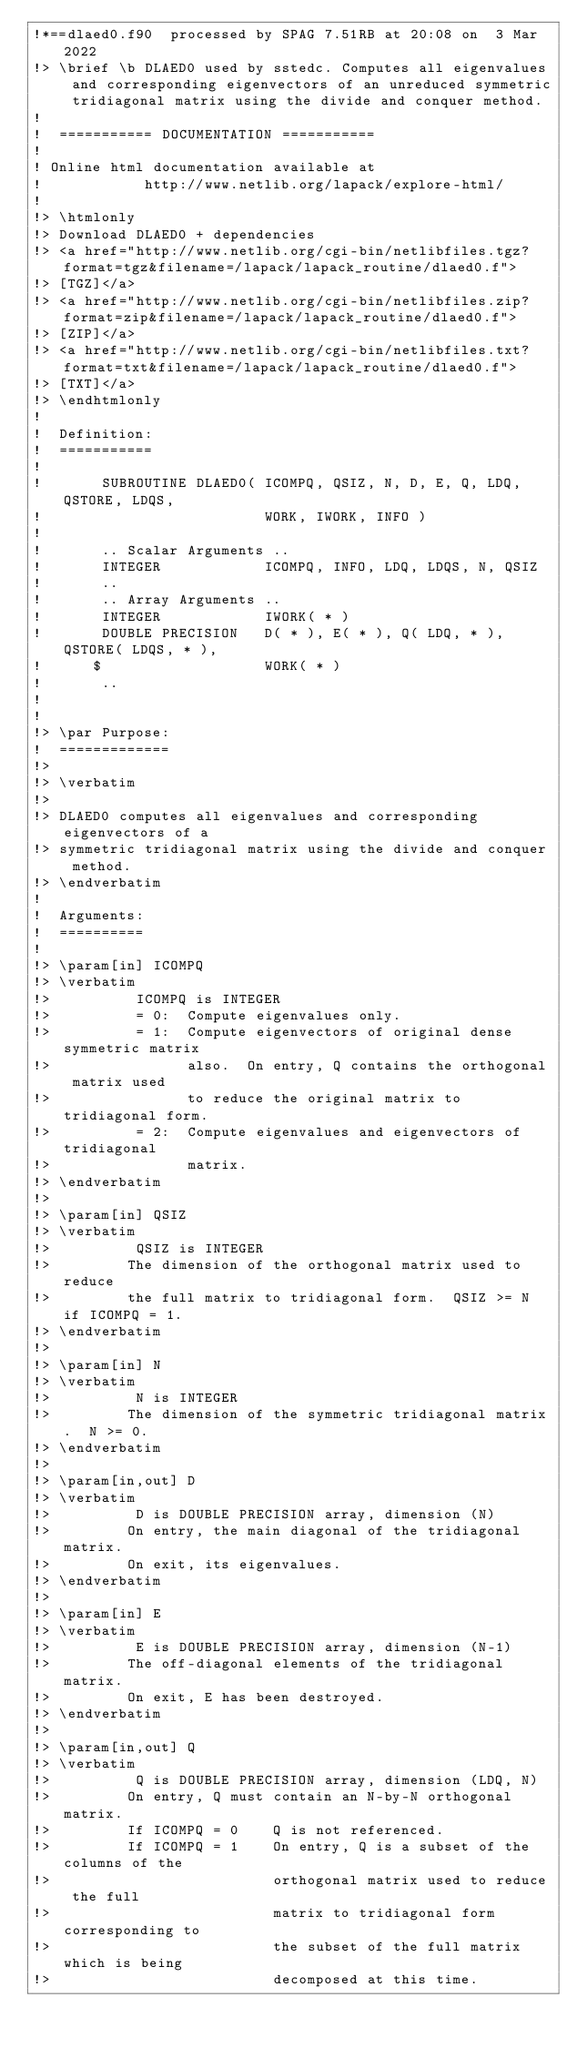Convert code to text. <code><loc_0><loc_0><loc_500><loc_500><_FORTRAN_>!*==dlaed0.f90  processed by SPAG 7.51RB at 20:08 on  3 Mar 2022
!> \brief \b DLAED0 used by sstedc. Computes all eigenvalues and corresponding eigenvectors of an unreduced symmetric tridiagonal matrix using the divide and conquer method.
!
!  =========== DOCUMENTATION ===========
!
! Online html documentation available at
!            http://www.netlib.org/lapack/explore-html/
!
!> \htmlonly
!> Download DLAED0 + dependencies
!> <a href="http://www.netlib.org/cgi-bin/netlibfiles.tgz?format=tgz&filename=/lapack/lapack_routine/dlaed0.f">
!> [TGZ]</a>
!> <a href="http://www.netlib.org/cgi-bin/netlibfiles.zip?format=zip&filename=/lapack/lapack_routine/dlaed0.f">
!> [ZIP]</a>
!> <a href="http://www.netlib.org/cgi-bin/netlibfiles.txt?format=txt&filename=/lapack/lapack_routine/dlaed0.f">
!> [TXT]</a>
!> \endhtmlonly
!
!  Definition:
!  ===========
!
!       SUBROUTINE DLAED0( ICOMPQ, QSIZ, N, D, E, Q, LDQ, QSTORE, LDQS,
!                          WORK, IWORK, INFO )
!
!       .. Scalar Arguments ..
!       INTEGER            ICOMPQ, INFO, LDQ, LDQS, N, QSIZ
!       ..
!       .. Array Arguments ..
!       INTEGER            IWORK( * )
!       DOUBLE PRECISION   D( * ), E( * ), Q( LDQ, * ), QSTORE( LDQS, * ),
!      $                   WORK( * )
!       ..
!
!
!> \par Purpose:
!  =============
!>
!> \verbatim
!>
!> DLAED0 computes all eigenvalues and corresponding eigenvectors of a
!> symmetric tridiagonal matrix using the divide and conquer method.
!> \endverbatim
!
!  Arguments:
!  ==========
!
!> \param[in] ICOMPQ
!> \verbatim
!>          ICOMPQ is INTEGER
!>          = 0:  Compute eigenvalues only.
!>          = 1:  Compute eigenvectors of original dense symmetric matrix
!>                also.  On entry, Q contains the orthogonal matrix used
!>                to reduce the original matrix to tridiagonal form.
!>          = 2:  Compute eigenvalues and eigenvectors of tridiagonal
!>                matrix.
!> \endverbatim
!>
!> \param[in] QSIZ
!> \verbatim
!>          QSIZ is INTEGER
!>         The dimension of the orthogonal matrix used to reduce
!>         the full matrix to tridiagonal form.  QSIZ >= N if ICOMPQ = 1.
!> \endverbatim
!>
!> \param[in] N
!> \verbatim
!>          N is INTEGER
!>         The dimension of the symmetric tridiagonal matrix.  N >= 0.
!> \endverbatim
!>
!> \param[in,out] D
!> \verbatim
!>          D is DOUBLE PRECISION array, dimension (N)
!>         On entry, the main diagonal of the tridiagonal matrix.
!>         On exit, its eigenvalues.
!> \endverbatim
!>
!> \param[in] E
!> \verbatim
!>          E is DOUBLE PRECISION array, dimension (N-1)
!>         The off-diagonal elements of the tridiagonal matrix.
!>         On exit, E has been destroyed.
!> \endverbatim
!>
!> \param[in,out] Q
!> \verbatim
!>          Q is DOUBLE PRECISION array, dimension (LDQ, N)
!>         On entry, Q must contain an N-by-N orthogonal matrix.
!>         If ICOMPQ = 0    Q is not referenced.
!>         If ICOMPQ = 1    On entry, Q is a subset of the columns of the
!>                          orthogonal matrix used to reduce the full
!>                          matrix to tridiagonal form corresponding to
!>                          the subset of the full matrix which is being
!>                          decomposed at this time.</code> 